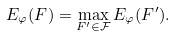Convert formula to latex. <formula><loc_0><loc_0><loc_500><loc_500>E _ { \varphi } ( F ) = \max _ { F ^ { \prime } \in \mathcal { F } } E _ { \varphi } ( F ^ { \prime } ) .</formula> 